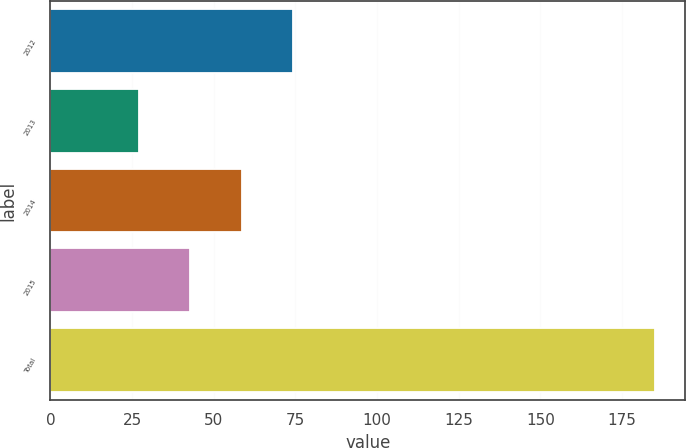Convert chart to OTSL. <chart><loc_0><loc_0><loc_500><loc_500><bar_chart><fcel>2012<fcel>2013<fcel>2014<fcel>2015<fcel>Total<nl><fcel>74.4<fcel>27<fcel>58.6<fcel>42.8<fcel>185<nl></chart> 